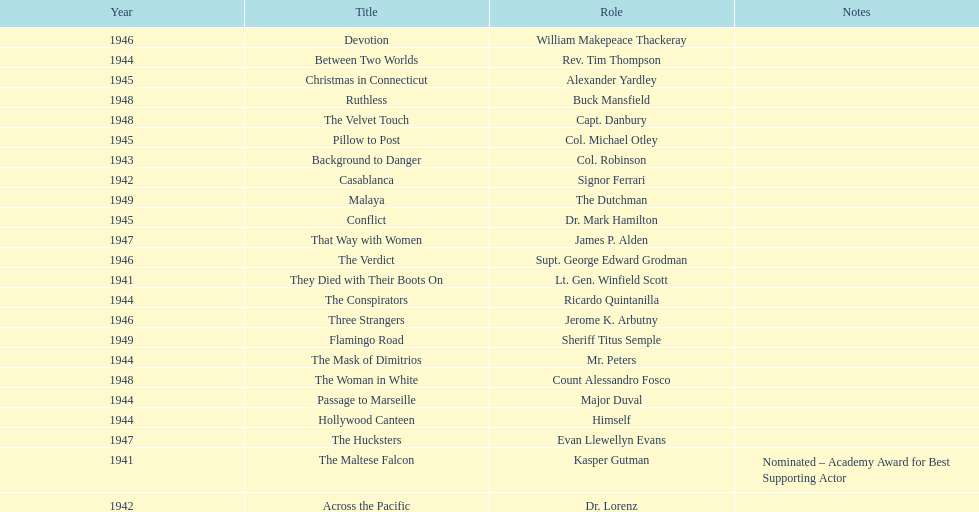What movies did greenstreet act for in 1946? Three Strangers, Devotion, The Verdict. 